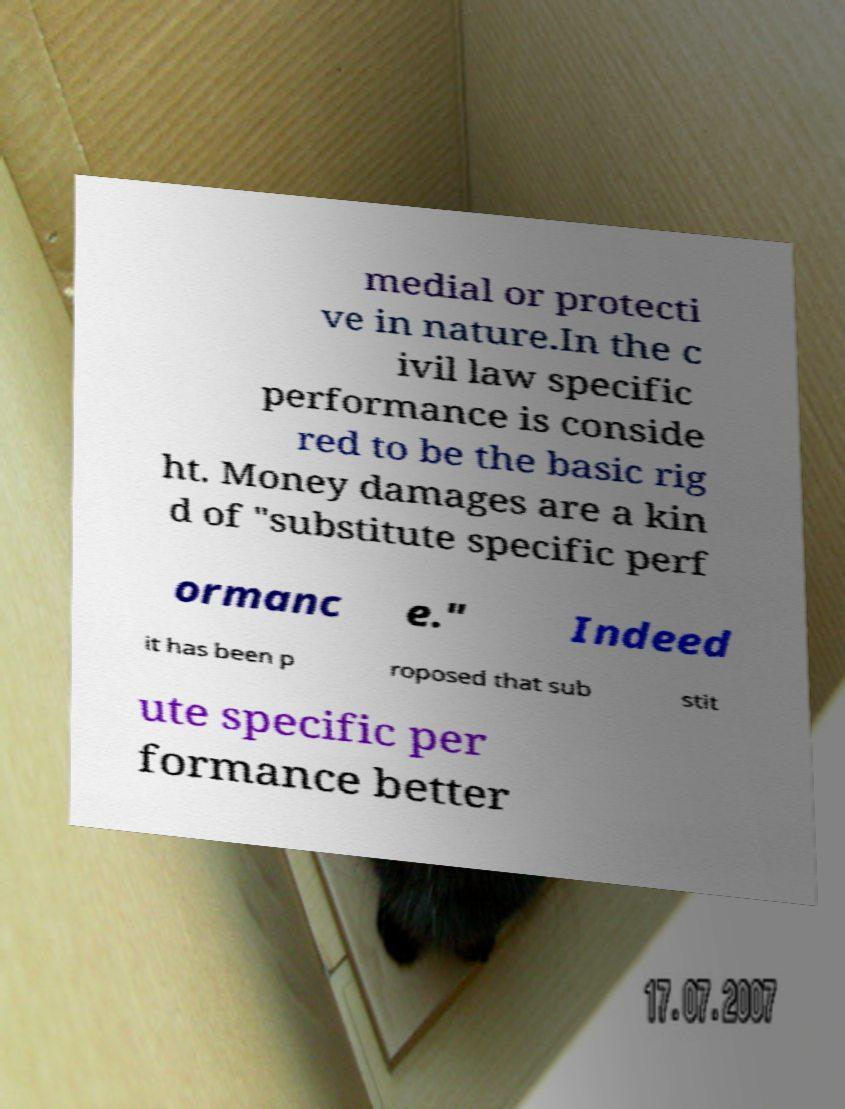Can you read and provide the text displayed in the image?This photo seems to have some interesting text. Can you extract and type it out for me? medial or protecti ve in nature.In the c ivil law specific performance is conside red to be the basic rig ht. Money damages are a kin d of "substitute specific perf ormanc e." Indeed it has been p roposed that sub stit ute specific per formance better 